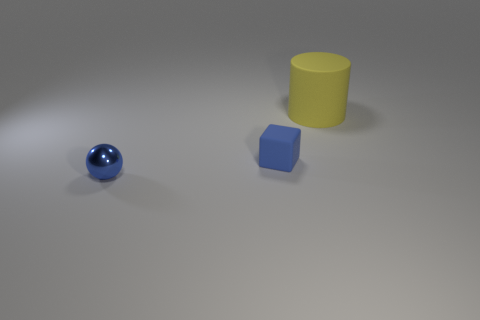Add 1 metallic balls. How many objects exist? 4 Subtract all cylinders. How many objects are left? 2 Subtract all rubber cylinders. Subtract all purple matte balls. How many objects are left? 2 Add 3 small objects. How many small objects are left? 5 Add 1 blue metal balls. How many blue metal balls exist? 2 Subtract 1 blue cubes. How many objects are left? 2 